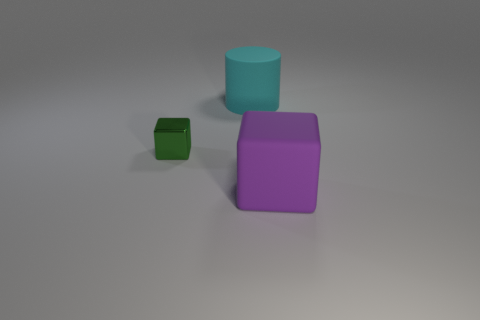Add 3 large green metallic balls. How many objects exist? 6 Subtract all cylinders. How many objects are left? 2 Subtract 0 blue cubes. How many objects are left? 3 Subtract all tiny things. Subtract all cyan objects. How many objects are left? 1 Add 1 large purple rubber objects. How many large purple rubber objects are left? 2 Add 1 brown metallic spheres. How many brown metallic spheres exist? 1 